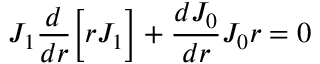<formula> <loc_0><loc_0><loc_500><loc_500>J _ { 1 } \frac { d } { d r } \left [ r J _ { 1 } \right ] + \frac { d J _ { 0 } } { d r } J _ { 0 } r = 0</formula> 